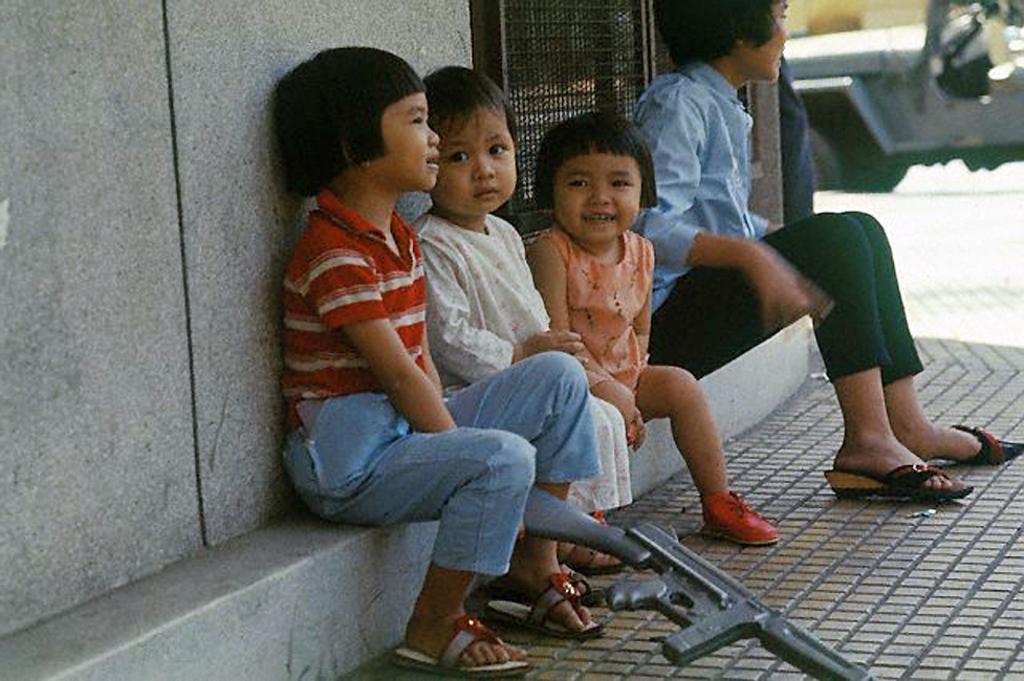Describe this image in one or two sentences. In the image we can see there are kids sitting on the footpath and there is a girl sitting beside them. There is a vehicle parked on the road and there is a kid holding rifle in her hand. 